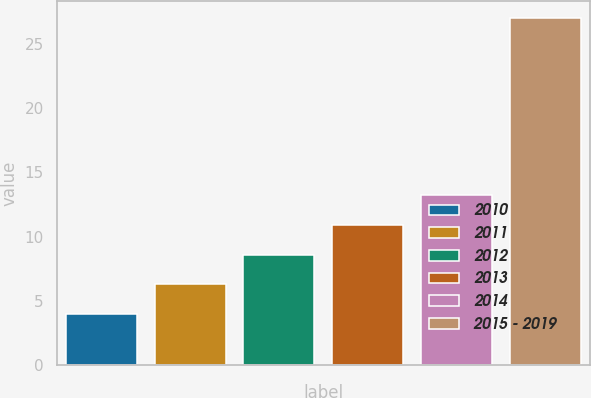Convert chart to OTSL. <chart><loc_0><loc_0><loc_500><loc_500><bar_chart><fcel>2010<fcel>2011<fcel>2012<fcel>2013<fcel>2014<fcel>2015 - 2019<nl><fcel>4<fcel>6.3<fcel>8.6<fcel>10.9<fcel>13.2<fcel>27<nl></chart> 